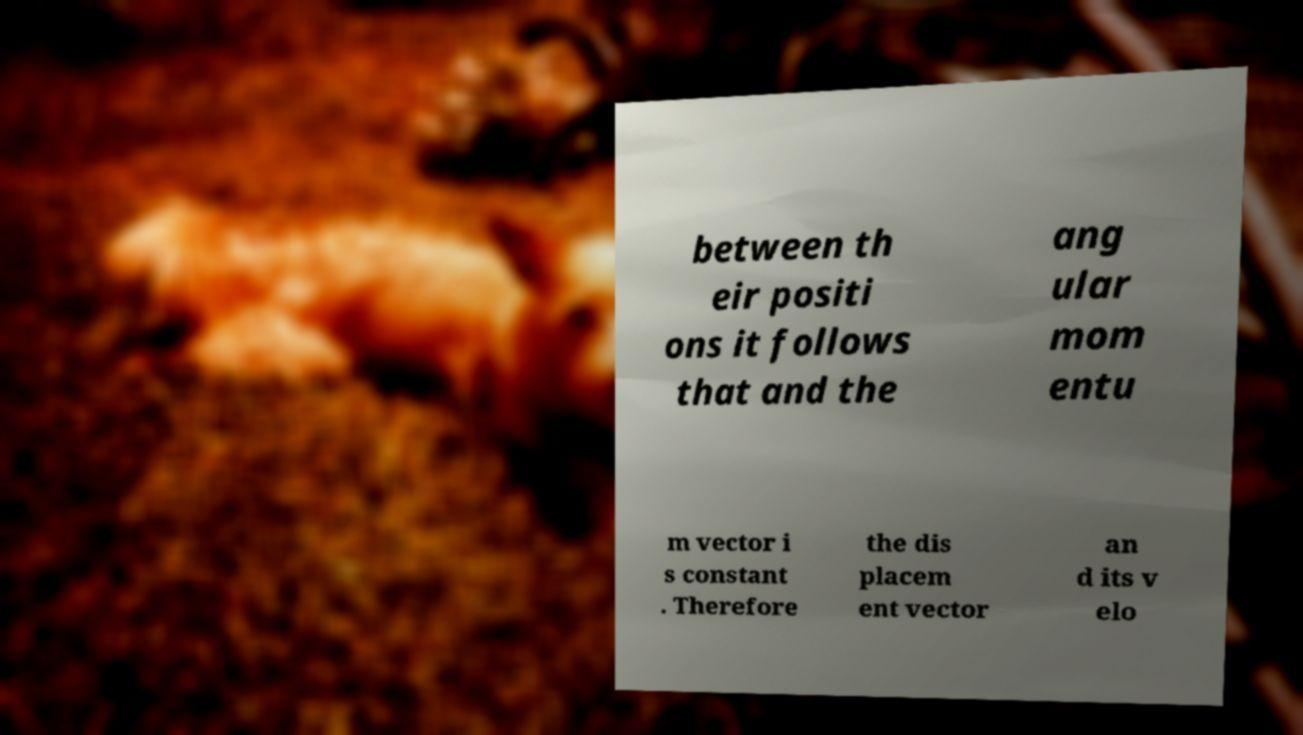Please identify and transcribe the text found in this image. between th eir positi ons it follows that and the ang ular mom entu m vector i s constant . Therefore the dis placem ent vector an d its v elo 